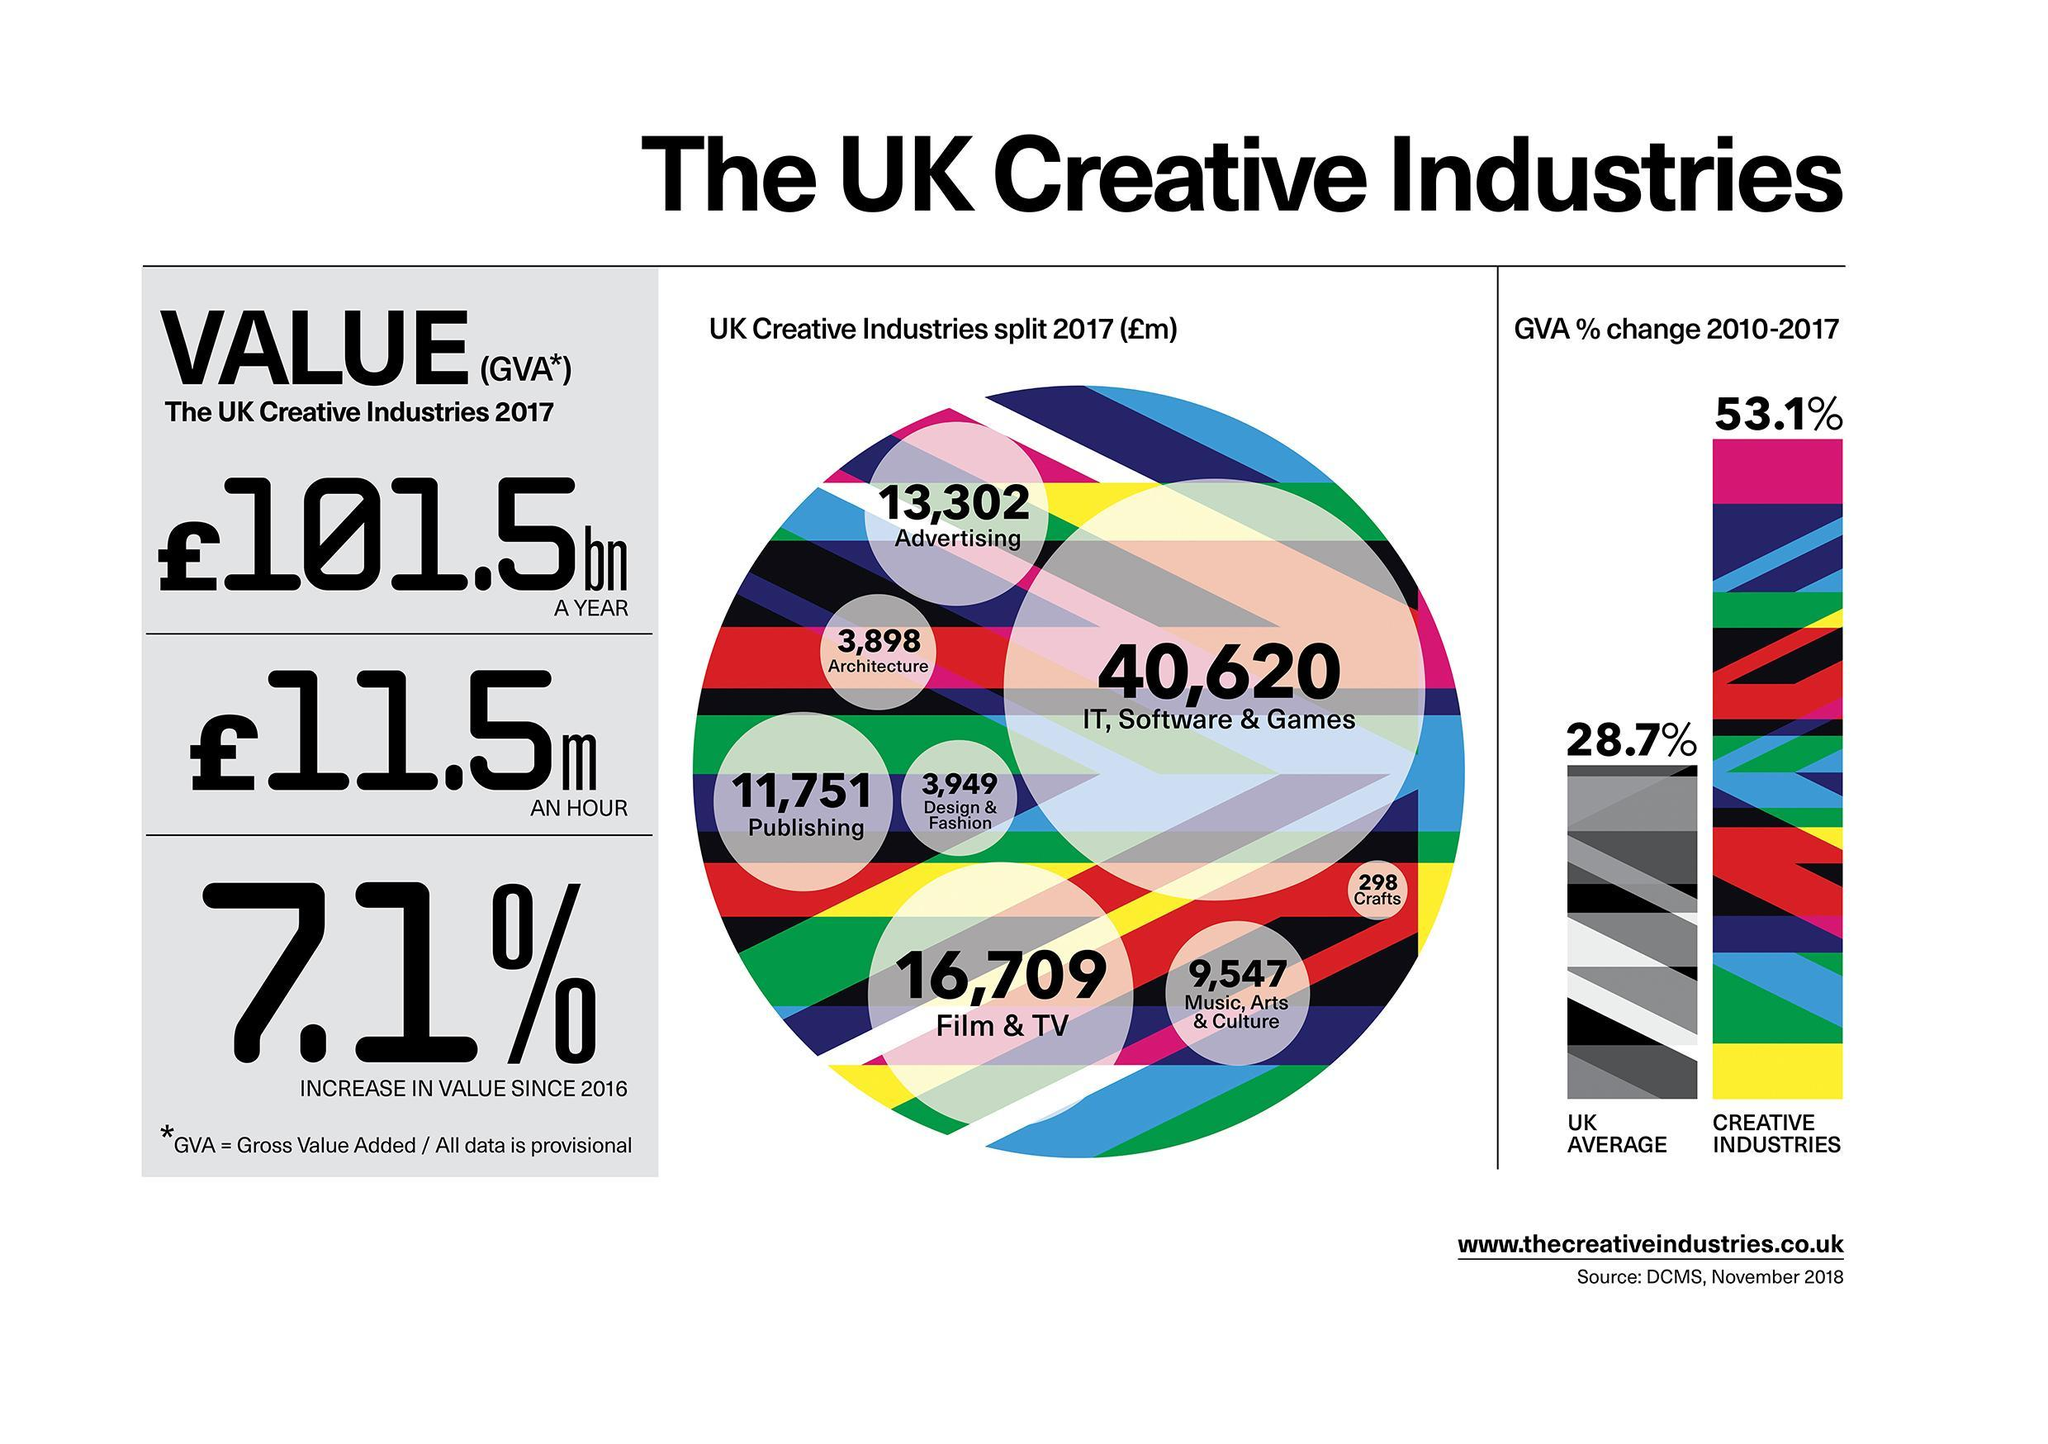What is the value share by Architecture and Design and Fashion
Answer the question with a short phrase. 7847 How much higher in value is Publishing when compared to Music, Arts & Culture 2204 Which creative industry has the least share Crafts Which creative industry has the major share IT, Software & Games How much higher is the GVA % highers for creative industries than the UK average 24.4 What is the value of the UK creative industries in an hour 11.5m 